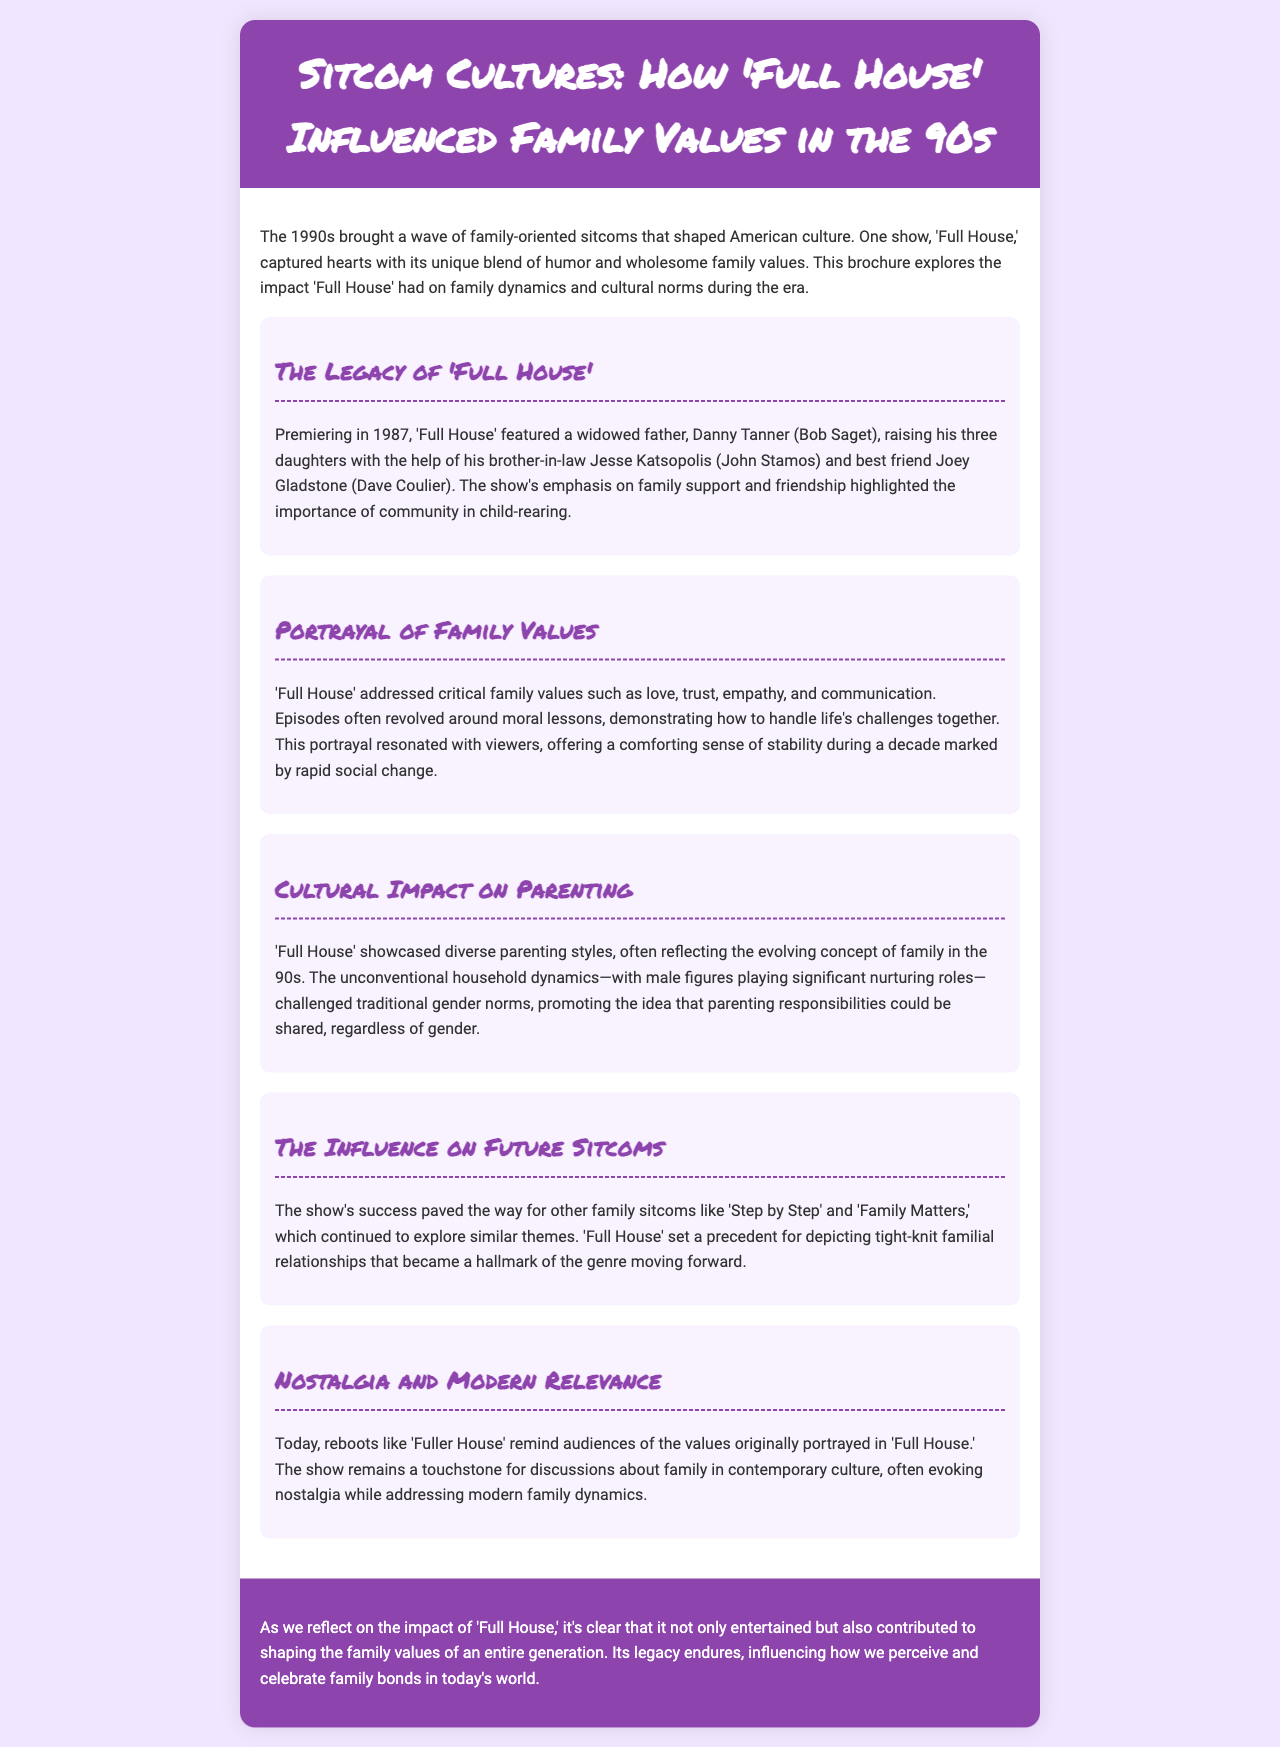what year did 'Full House' premiere? The document states that 'Full House' premiered in 1987.
Answer: 1987 who are the main characters featured in 'Full House'? The brochure lists Danny Tanner, Jesse Katsopolis, and Joey Gladstone as the main characters.
Answer: Danny Tanner, Jesse Katsopolis, Joey Gladstone what key family values does 'Full House' address? The document mentions love, trust, empathy, and communication as key family values.
Answer: love, trust, empathy, communication how did 'Full House' influence future sitcoms? The brochure states that 'Full House' paved the way for shows like 'Step by Step' and 'Family Matters'.
Answer: 'Step by Step', 'Family Matters' what was one way 'Full House' challenged traditional gender norms? The document explains that male figures played significant nurturing roles within the family structure.
Answer: male nurturing roles 